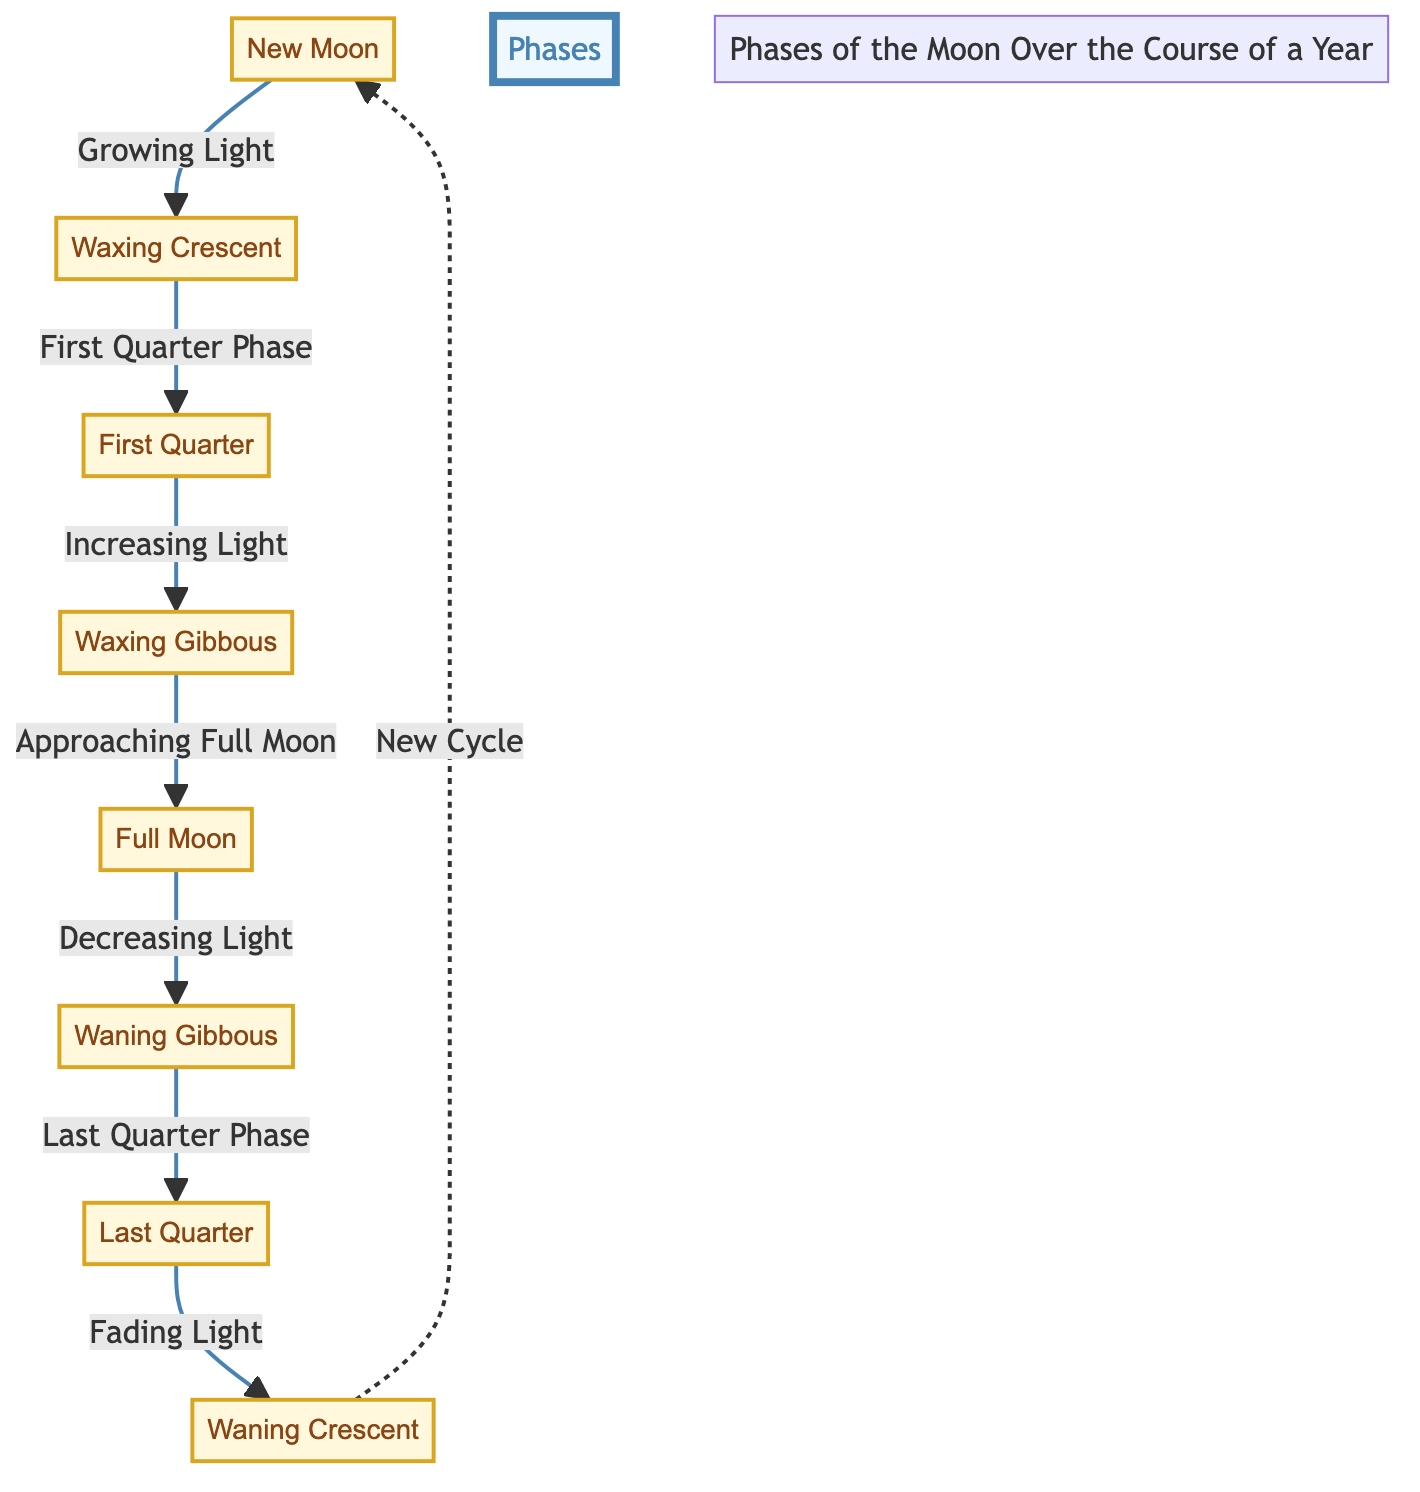What are the eight phases of the moon? The diagram lists the eight phases of the moon as follows: New Moon, Waxing Crescent, First Quarter, Waxing Gibbous, Full Moon, Waning Gibbous, Last Quarter, and Waning Crescent.
Answer: New Moon, Waxing Crescent, First Quarter, Waxing Gibbous, Full Moon, Waning Gibbous, Last Quarter, Waning Crescent Which phase comes after the Full Moon? The diagram shows that after the Full Moon, the moon enters the Waning Gibbous phase, indicating that the light of the moon is decreasing.
Answer: Waning Gibbous What is the relationship between the New Moon and the Waxing Crescent? The diagram indicates that the relationship is one of growing light, where the New Moon transitions into the Waxing Crescent phase as the light starts to increase.
Answer: Growing Light How many phases of the moon are shown in the diagram? The diagram clearly displays eight distinct phases of the moon, each labeled as separate nodes connected by directional arrows demonstrating their progression throughout the lunar cycle.
Answer: 8 What phase follows the Last Quarter? According to the diagram, after the Last Quarter, the moon moves into the Waning Crescent phase, indicating a continuation of decreased light towards the New Moon.
Answer: Waning Crescent How does the moon transition from Waxing Gibbous to Full Moon? The diagram points out that the Waxing Gibbous phase leads directly to the Full Moon phase, showing the approach to full illumination which characterizes this phase.
Answer: Approaching Full Moon What tells us the moon is transitioning into a new cycle? The diagram indicates that after the Waning Crescent phase, the moon cycles back to the New Moon, marked by the notation "New Cycle," highlighting the beginning of a new lunar cycle.
Answer: New Cycle What type of progression is represented from the First Quarter to the Waxing Gibbous? The diagram categorizes this transition as "Increasing Light," indicating that during this phase, the visible part of the moon is expanding towards fullness.
Answer: Increasing Light 